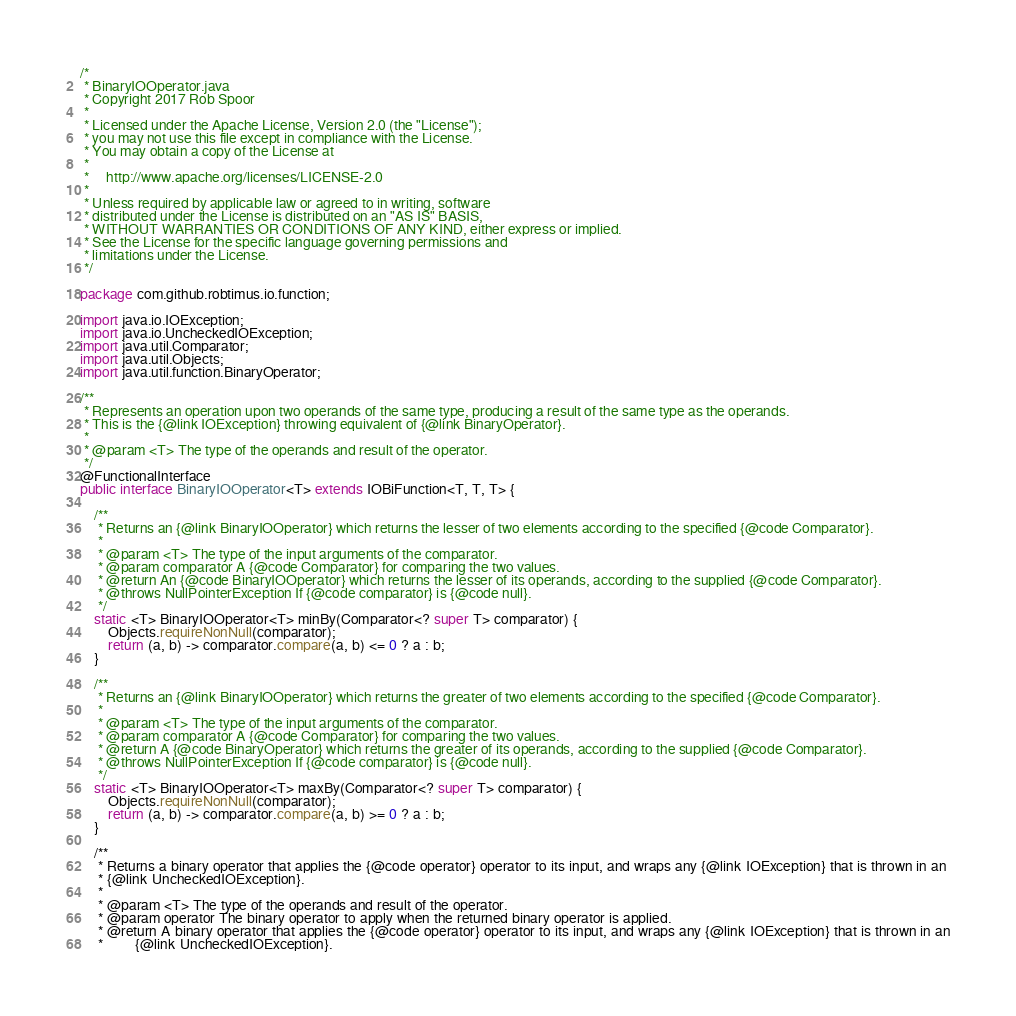Convert code to text. <code><loc_0><loc_0><loc_500><loc_500><_Java_>/*
 * BinaryIOOperator.java
 * Copyright 2017 Rob Spoor
 *
 * Licensed under the Apache License, Version 2.0 (the "License");
 * you may not use this file except in compliance with the License.
 * You may obtain a copy of the License at
 *
 *     http://www.apache.org/licenses/LICENSE-2.0
 *
 * Unless required by applicable law or agreed to in writing, software
 * distributed under the License is distributed on an "AS IS" BASIS,
 * WITHOUT WARRANTIES OR CONDITIONS OF ANY KIND, either express or implied.
 * See the License for the specific language governing permissions and
 * limitations under the License.
 */

package com.github.robtimus.io.function;

import java.io.IOException;
import java.io.UncheckedIOException;
import java.util.Comparator;
import java.util.Objects;
import java.util.function.BinaryOperator;

/**
 * Represents an operation upon two operands of the same type, producing a result of the same type as the operands.
 * This is the {@link IOException} throwing equivalent of {@link BinaryOperator}.
 *
 * @param <T> The type of the operands and result of the operator.
 */
@FunctionalInterface
public interface BinaryIOOperator<T> extends IOBiFunction<T, T, T> {

    /**
     * Returns an {@link BinaryIOOperator} which returns the lesser of two elements according to the specified {@code Comparator}.
     *
     * @param <T> The type of the input arguments of the comparator.
     * @param comparator A {@code Comparator} for comparing the two values.
     * @return An {@code BinaryIOOperator} which returns the lesser of its operands, according to the supplied {@code Comparator}.
     * @throws NullPointerException If {@code comparator} is {@code null}.
     */
    static <T> BinaryIOOperator<T> minBy(Comparator<? super T> comparator) {
        Objects.requireNonNull(comparator);
        return (a, b) -> comparator.compare(a, b) <= 0 ? a : b;
    }

    /**
     * Returns an {@link BinaryIOOperator} which returns the greater of two elements according to the specified {@code Comparator}.
     *
     * @param <T> The type of the input arguments of the comparator.
     * @param comparator A {@code Comparator} for comparing the two values.
     * @return A {@code BinaryOperator} which returns the greater of its operands, according to the supplied {@code Comparator}.
     * @throws NullPointerException If {@code comparator} is {@code null}.
     */
    static <T> BinaryIOOperator<T> maxBy(Comparator<? super T> comparator) {
        Objects.requireNonNull(comparator);
        return (a, b) -> comparator.compare(a, b) >= 0 ? a : b;
    }

    /**
     * Returns a binary operator that applies the {@code operator} operator to its input, and wraps any {@link IOException} that is thrown in an
     * {@link UncheckedIOException}.
     *
     * @param <T> The type of the operands and result of the operator.
     * @param operator The binary operator to apply when the returned binary operator is applied.
     * @return A binary operator that applies the {@code operator} operator to its input, and wraps any {@link IOException} that is thrown in an
     *         {@link UncheckedIOException}.</code> 